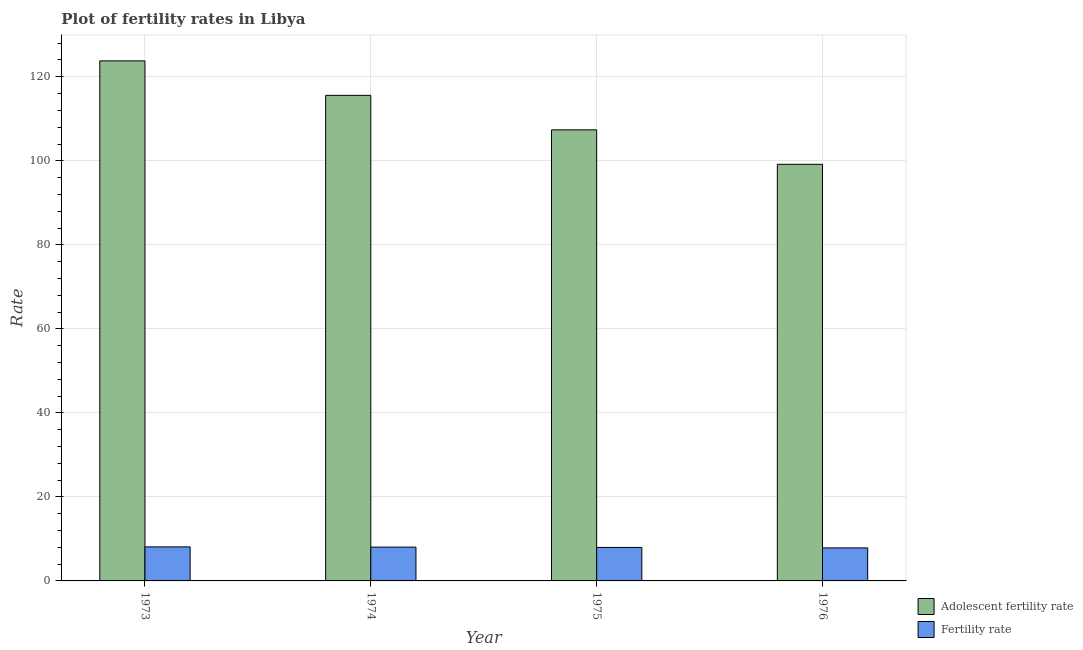How many different coloured bars are there?
Your answer should be compact. 2. How many bars are there on the 1st tick from the right?
Keep it short and to the point. 2. What is the label of the 4th group of bars from the left?
Provide a succinct answer. 1976. In how many cases, is the number of bars for a given year not equal to the number of legend labels?
Your answer should be compact. 0. What is the fertility rate in 1974?
Provide a succinct answer. 8.05. Across all years, what is the maximum fertility rate?
Offer a terse response. 8.1. Across all years, what is the minimum adolescent fertility rate?
Provide a short and direct response. 99.17. In which year was the fertility rate maximum?
Keep it short and to the point. 1973. In which year was the adolescent fertility rate minimum?
Your answer should be very brief. 1976. What is the total adolescent fertility rate in the graph?
Provide a short and direct response. 445.91. What is the difference between the fertility rate in 1973 and that in 1975?
Provide a short and direct response. 0.13. What is the difference between the fertility rate in 1976 and the adolescent fertility rate in 1975?
Offer a terse response. -0.1. What is the average adolescent fertility rate per year?
Make the answer very short. 111.48. In the year 1973, what is the difference between the fertility rate and adolescent fertility rate?
Give a very brief answer. 0. What is the ratio of the fertility rate in 1973 to that in 1975?
Give a very brief answer. 1.02. What is the difference between the highest and the second highest fertility rate?
Provide a succinct answer. 0.05. What is the difference between the highest and the lowest fertility rate?
Provide a short and direct response. 0.24. What does the 2nd bar from the left in 1975 represents?
Provide a short and direct response. Fertility rate. What does the 2nd bar from the right in 1973 represents?
Your response must be concise. Adolescent fertility rate. How many years are there in the graph?
Offer a terse response. 4. Does the graph contain any zero values?
Your response must be concise. No. Does the graph contain grids?
Provide a succinct answer. Yes. How many legend labels are there?
Your answer should be very brief. 2. How are the legend labels stacked?
Make the answer very short. Vertical. What is the title of the graph?
Keep it short and to the point. Plot of fertility rates in Libya. Does "Electricity" appear as one of the legend labels in the graph?
Provide a succinct answer. No. What is the label or title of the Y-axis?
Provide a short and direct response. Rate. What is the Rate in Adolescent fertility rate in 1973?
Ensure brevity in your answer.  123.79. What is the Rate in Fertility rate in 1973?
Your answer should be compact. 8.1. What is the Rate in Adolescent fertility rate in 1974?
Give a very brief answer. 115.58. What is the Rate in Fertility rate in 1974?
Provide a succinct answer. 8.05. What is the Rate of Adolescent fertility rate in 1975?
Provide a short and direct response. 107.37. What is the Rate of Fertility rate in 1975?
Ensure brevity in your answer.  7.97. What is the Rate of Adolescent fertility rate in 1976?
Your answer should be very brief. 99.17. What is the Rate of Fertility rate in 1976?
Offer a very short reply. 7.87. Across all years, what is the maximum Rate of Adolescent fertility rate?
Your response must be concise. 123.79. Across all years, what is the maximum Rate of Fertility rate?
Your answer should be compact. 8.1. Across all years, what is the minimum Rate in Adolescent fertility rate?
Your answer should be compact. 99.17. Across all years, what is the minimum Rate in Fertility rate?
Give a very brief answer. 7.87. What is the total Rate in Adolescent fertility rate in the graph?
Give a very brief answer. 445.91. What is the total Rate in Fertility rate in the graph?
Provide a short and direct response. 31.99. What is the difference between the Rate of Adolescent fertility rate in 1973 and that in 1974?
Provide a short and direct response. 8.21. What is the difference between the Rate in Fertility rate in 1973 and that in 1974?
Ensure brevity in your answer.  0.05. What is the difference between the Rate of Adolescent fertility rate in 1973 and that in 1975?
Offer a very short reply. 16.42. What is the difference between the Rate of Fertility rate in 1973 and that in 1975?
Provide a short and direct response. 0.13. What is the difference between the Rate of Adolescent fertility rate in 1973 and that in 1976?
Offer a very short reply. 24.63. What is the difference between the Rate of Fertility rate in 1973 and that in 1976?
Your answer should be compact. 0.24. What is the difference between the Rate in Adolescent fertility rate in 1974 and that in 1975?
Offer a very short reply. 8.21. What is the difference between the Rate in Fertility rate in 1974 and that in 1975?
Ensure brevity in your answer.  0.08. What is the difference between the Rate of Adolescent fertility rate in 1974 and that in 1976?
Your answer should be compact. 16.42. What is the difference between the Rate of Fertility rate in 1974 and that in 1976?
Offer a terse response. 0.18. What is the difference between the Rate in Adolescent fertility rate in 1975 and that in 1976?
Give a very brief answer. 8.21. What is the difference between the Rate in Fertility rate in 1975 and that in 1976?
Provide a succinct answer. 0.1. What is the difference between the Rate of Adolescent fertility rate in 1973 and the Rate of Fertility rate in 1974?
Offer a terse response. 115.74. What is the difference between the Rate in Adolescent fertility rate in 1973 and the Rate in Fertility rate in 1975?
Offer a terse response. 115.82. What is the difference between the Rate in Adolescent fertility rate in 1973 and the Rate in Fertility rate in 1976?
Provide a short and direct response. 115.92. What is the difference between the Rate of Adolescent fertility rate in 1974 and the Rate of Fertility rate in 1975?
Make the answer very short. 107.61. What is the difference between the Rate of Adolescent fertility rate in 1974 and the Rate of Fertility rate in 1976?
Your response must be concise. 107.72. What is the difference between the Rate in Adolescent fertility rate in 1975 and the Rate in Fertility rate in 1976?
Keep it short and to the point. 99.51. What is the average Rate in Adolescent fertility rate per year?
Your response must be concise. 111.48. What is the average Rate of Fertility rate per year?
Offer a very short reply. 8. In the year 1973, what is the difference between the Rate of Adolescent fertility rate and Rate of Fertility rate?
Keep it short and to the point. 115.69. In the year 1974, what is the difference between the Rate in Adolescent fertility rate and Rate in Fertility rate?
Make the answer very short. 107.53. In the year 1975, what is the difference between the Rate of Adolescent fertility rate and Rate of Fertility rate?
Make the answer very short. 99.4. In the year 1976, what is the difference between the Rate of Adolescent fertility rate and Rate of Fertility rate?
Keep it short and to the point. 91.3. What is the ratio of the Rate of Adolescent fertility rate in 1973 to that in 1974?
Provide a short and direct response. 1.07. What is the ratio of the Rate of Adolescent fertility rate in 1973 to that in 1975?
Provide a short and direct response. 1.15. What is the ratio of the Rate in Fertility rate in 1973 to that in 1975?
Provide a short and direct response. 1.02. What is the ratio of the Rate in Adolescent fertility rate in 1973 to that in 1976?
Make the answer very short. 1.25. What is the ratio of the Rate of Fertility rate in 1973 to that in 1976?
Your response must be concise. 1.03. What is the ratio of the Rate in Adolescent fertility rate in 1974 to that in 1975?
Ensure brevity in your answer.  1.08. What is the ratio of the Rate in Fertility rate in 1974 to that in 1975?
Provide a succinct answer. 1.01. What is the ratio of the Rate of Adolescent fertility rate in 1974 to that in 1976?
Give a very brief answer. 1.17. What is the ratio of the Rate in Fertility rate in 1974 to that in 1976?
Provide a succinct answer. 1.02. What is the ratio of the Rate in Adolescent fertility rate in 1975 to that in 1976?
Make the answer very short. 1.08. What is the ratio of the Rate of Fertility rate in 1975 to that in 1976?
Your answer should be compact. 1.01. What is the difference between the highest and the second highest Rate of Adolescent fertility rate?
Ensure brevity in your answer.  8.21. What is the difference between the highest and the second highest Rate of Fertility rate?
Give a very brief answer. 0.05. What is the difference between the highest and the lowest Rate of Adolescent fertility rate?
Keep it short and to the point. 24.63. What is the difference between the highest and the lowest Rate of Fertility rate?
Make the answer very short. 0.24. 